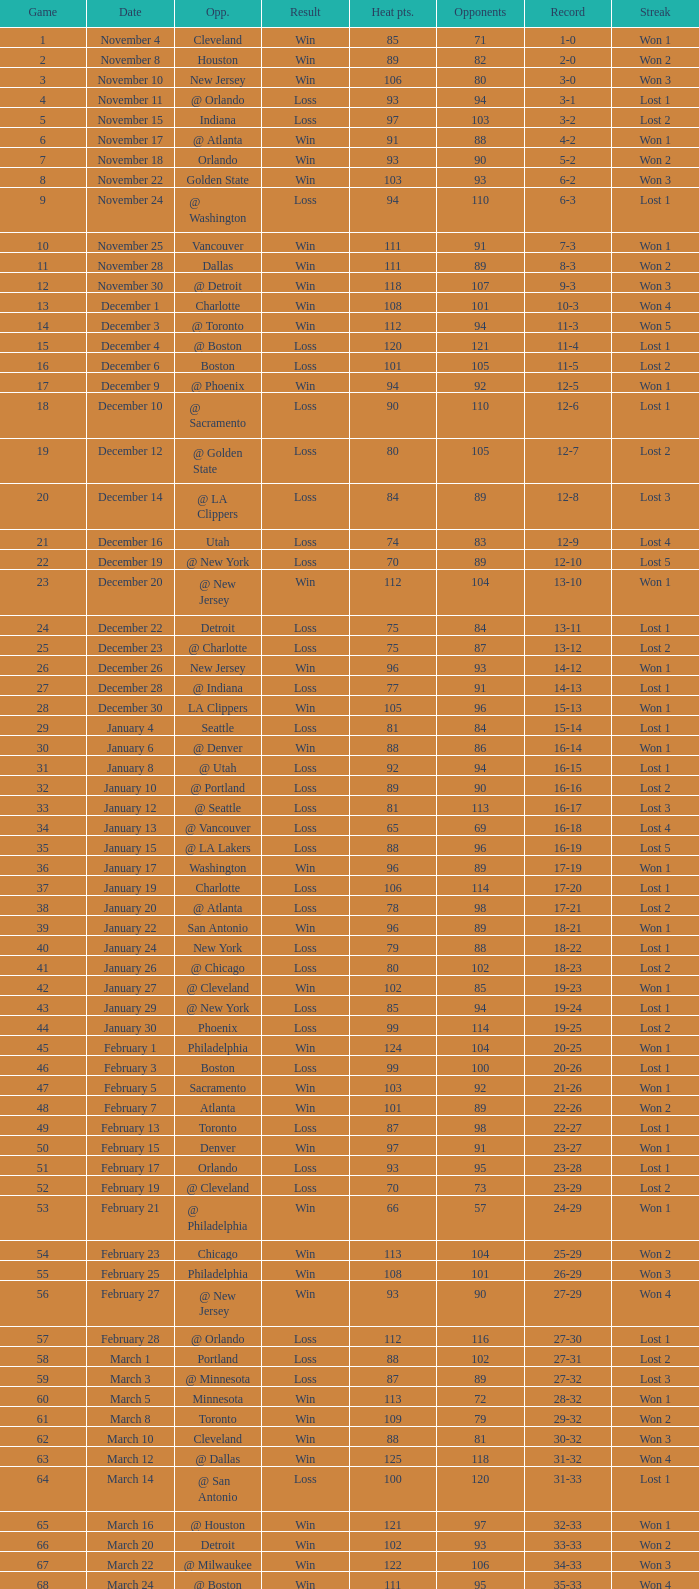What is the highest Game, when Opponents is less than 80, and when Record is "1-0"? 1.0. 